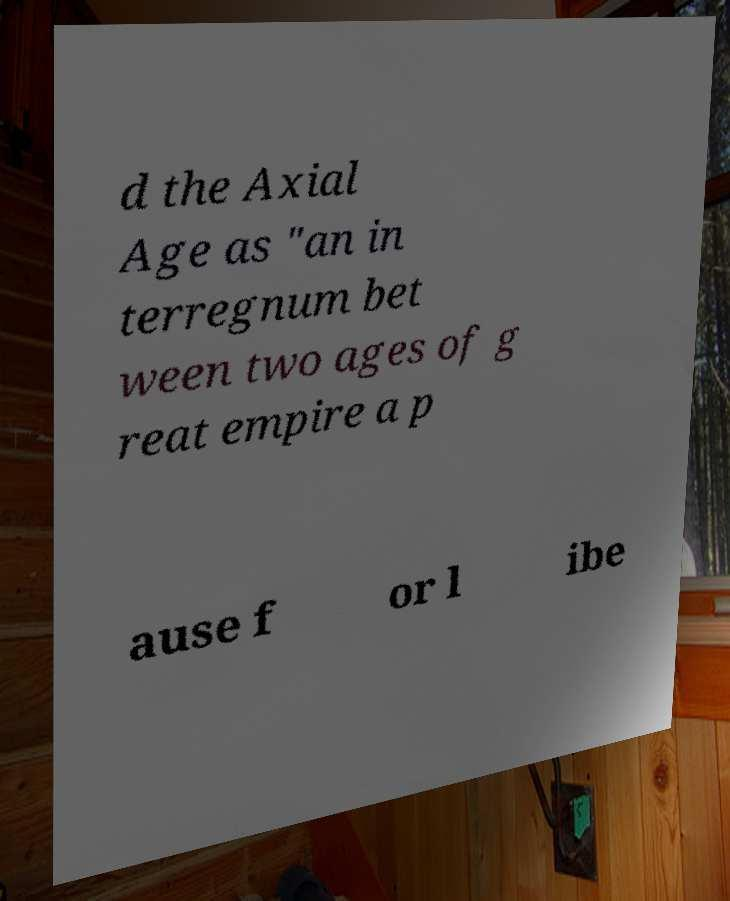Can you accurately transcribe the text from the provided image for me? d the Axial Age as "an in terregnum bet ween two ages of g reat empire a p ause f or l ibe 